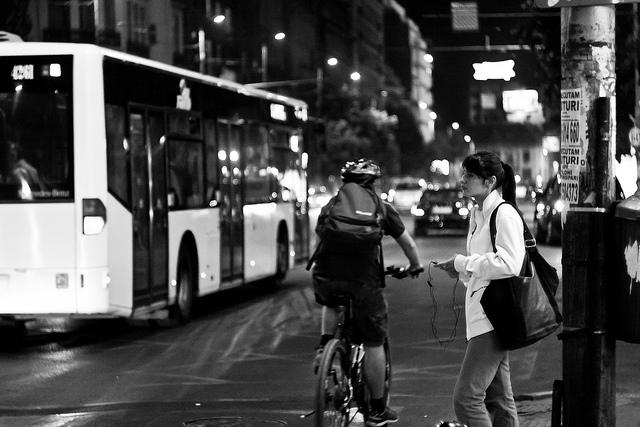What should the bus use to safely move in front of the bicyclist? Please explain your reasoning. turning signals. The bus uses a light to signal the bike rider. 